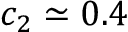Convert formula to latex. <formula><loc_0><loc_0><loc_500><loc_500>c _ { 2 } \simeq 0 . 4</formula> 